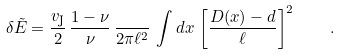<formula> <loc_0><loc_0><loc_500><loc_500>\delta \tilde { E } = \frac { v _ { \text {J} } } { 2 } \, \frac { 1 - \nu } { \nu } \, \frac { } { 2 \pi \ell ^ { 2 } } \, \int d x \, \left [ \frac { D ( x ) - d } { \ell } \right ] ^ { 2 } \quad .</formula> 